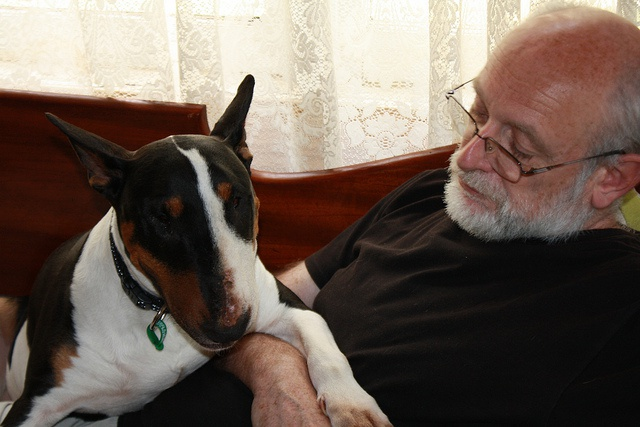Describe the objects in this image and their specific colors. I can see people in ivory, black, brown, and gray tones, dog in ivory, black, darkgray, gray, and maroon tones, and couch in ivory, black, maroon, gray, and darkgray tones in this image. 